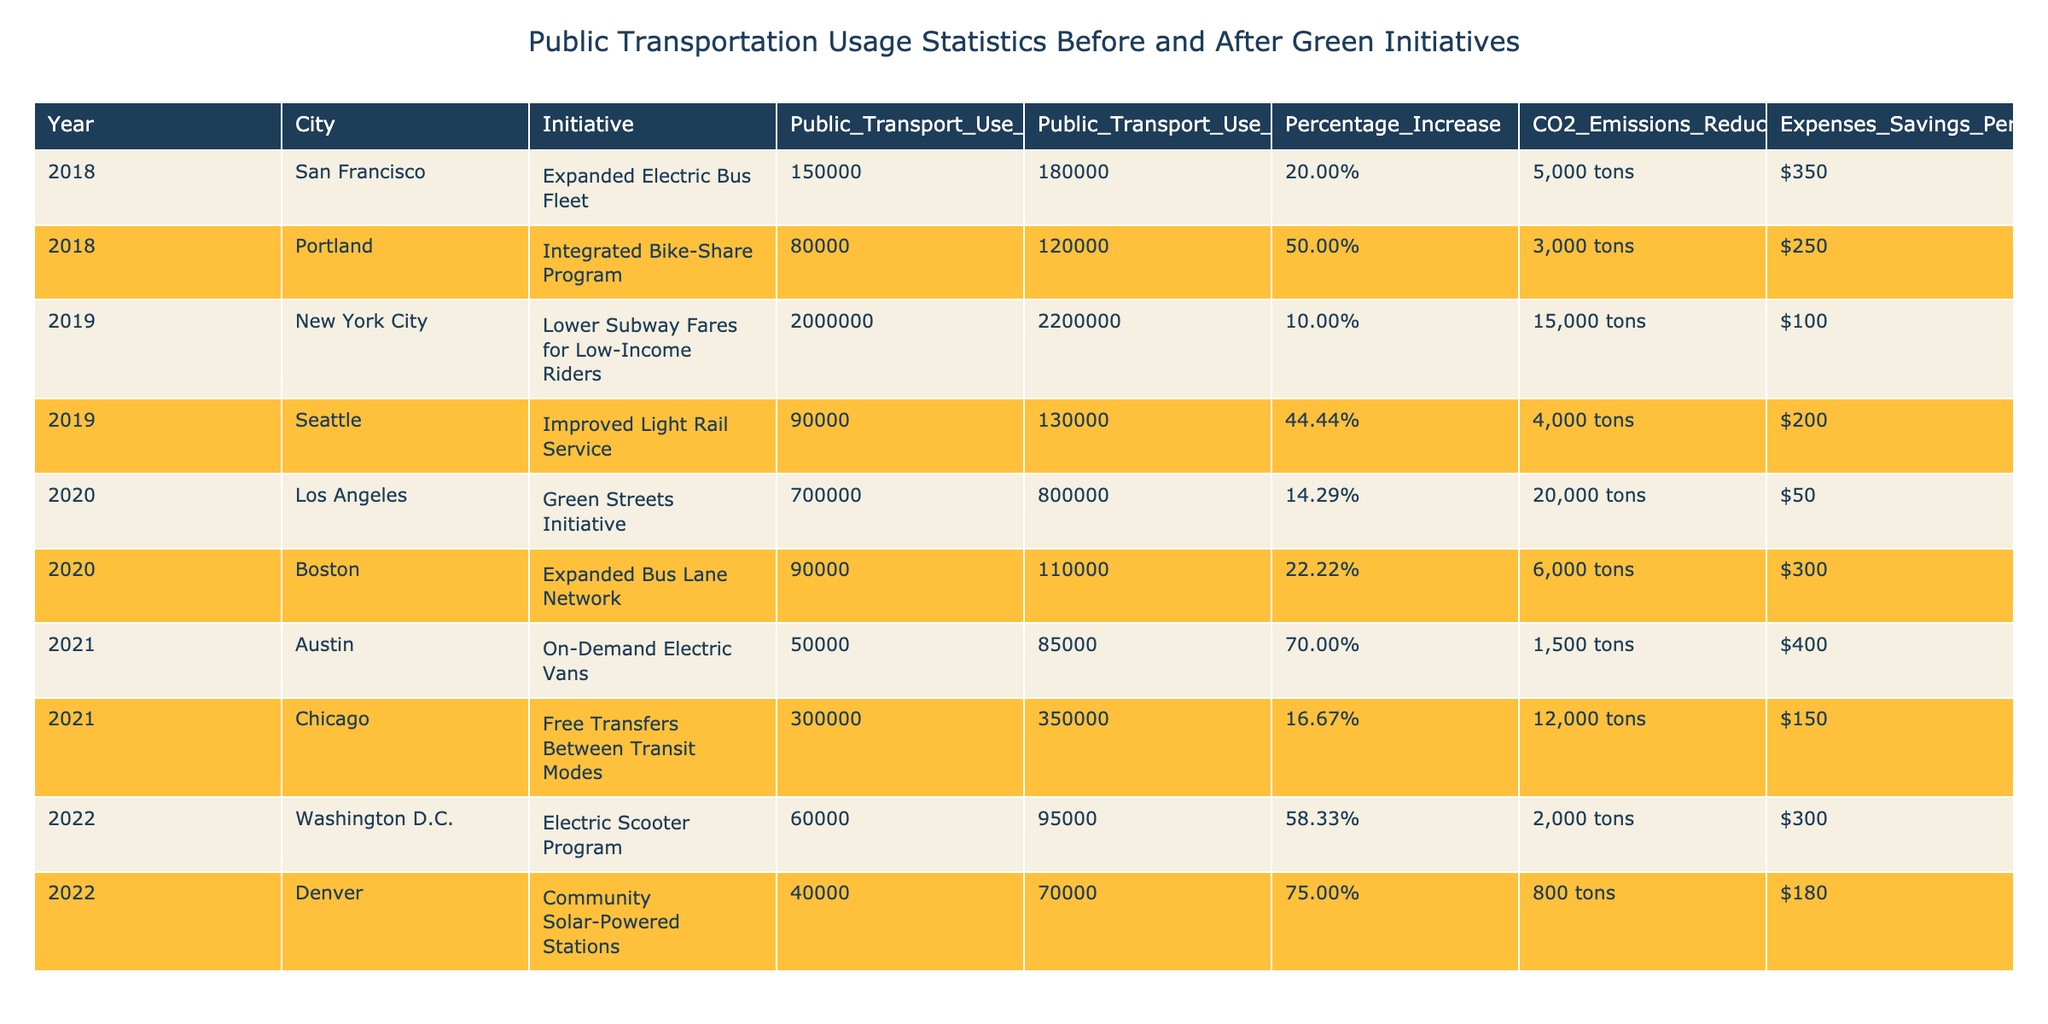What was the percentage increase in public transport use after the initiative in Seattle? According to the table, the percentage increase in public transport use after the initiative in Seattle is listed as 44.44%.
Answer: 44.44% Which city saw the highest CO2 emissions reduction among the given green initiatives? From the table, Los Angeles had the highest CO2 emissions reduction of 20,000 tons, compared to other cities' reductions.
Answer: Los Angeles What is the average expenses savings per user across all initiatives in the table? The expenses savings for each initiative are $350, $250, $100, $200, $50, $300, $400, $150, $300, and $180. Summing these gives $2,480, and dividing by 10 (the number of initiatives) results in an average of $248.
Answer: $248 Did the initiative in Austin result in a decrease in public transport usage? The table indicates that Austin's initiative led to an increase in public transport usage from 50,000 to 85,000, hence it did not decrease.
Answer: No Which cities have a public transport usage above 100,000 after the implementation of their initiatives? The cities with public transport usage above 100,000 after the initiatives are New York City (2,200,000), Los Angeles (800,000), Chicago (350,000), and Portland (120,000).
Answer: New York City, Los Angeles, Chicago, Portland What was the difference in percentage increase between the initiatives in Denver and Austin? Denver saw a percentage increase of 75.00%, while Austin's percentage increase was 70.00%. The difference is 75.00% - 70.00% = 5.00%.
Answer: 5.00% Is there a relationship between CO2 emissions reduction and the percentage increase in public transport use for the initiatives listed? Analyzing the data, cities with higher percentage increases (e.g., Denver and Austin) also show significant CO2 emissions reductions, suggesting a possible relationship.
Answer: Yes How much CO2 emissions reduction is associated with the initiative in Portland? The table lists a CO2 emissions reduction of 3,000 tons for Portland's initiative.
Answer: 3,000 tons Which initiative provided the greatest savings per user? According to the table, the initiative in Austin provided the greatest savings per user at $400.
Answer: $400 In which year did the initiative with the lowest percentage increase take place? The initiative with the lowest percentage increase of 10.00% took place in New York City in 2019.
Answer: 2019 What is the total CO2 emissions reduction from all initiatives combined? Adding all the CO2 emissions reduction values from each initiative gives: 5000 + 3000 + 15000 + 4000 + 20000 + 6000 + 1500 + 12000 + 2000 + 800 =  55,000 tons.
Answer: 55,000 tons 